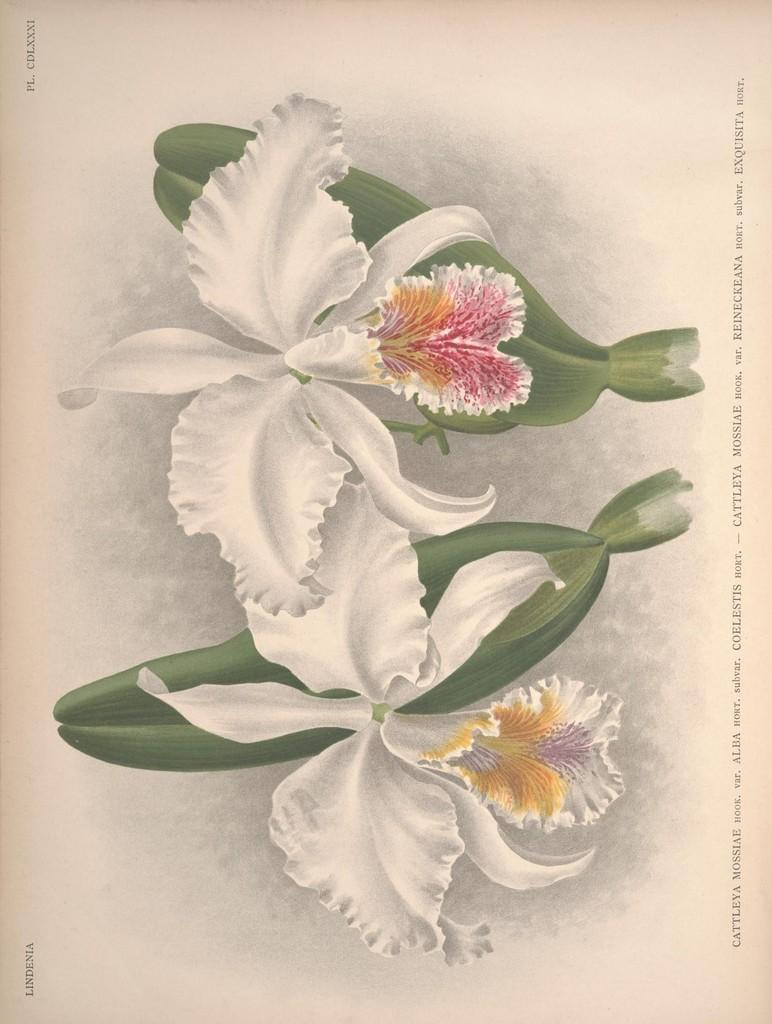What type of artwork is the image? The image is a painting. What type of natural elements are depicted in the painting? There are flowers depicted in the painting. Are there any words or letters present in the painting? Yes, there is text present in the painting. What type of farming equipment can be seen in the painting? There is no farming equipment, such as a plough, present in the painting. How many sticks are visible in the painting? There are no sticks depicted in the painting. 